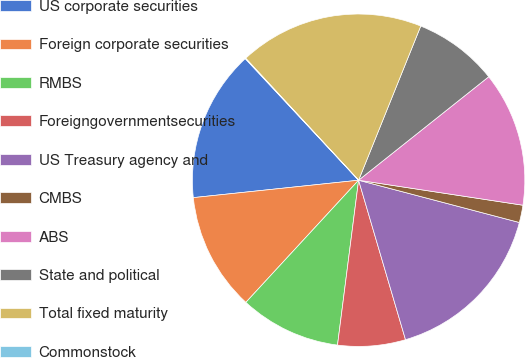Convert chart. <chart><loc_0><loc_0><loc_500><loc_500><pie_chart><fcel>US corporate securities<fcel>Foreign corporate securities<fcel>RMBS<fcel>Foreigngovernmentsecurities<fcel>US Treasury agency and<fcel>CMBS<fcel>ABS<fcel>State and political<fcel>Total fixed maturity<fcel>Commonstock<nl><fcel>14.73%<fcel>11.47%<fcel>9.84%<fcel>6.58%<fcel>16.36%<fcel>1.69%<fcel>13.1%<fcel>8.21%<fcel>17.99%<fcel>0.06%<nl></chart> 